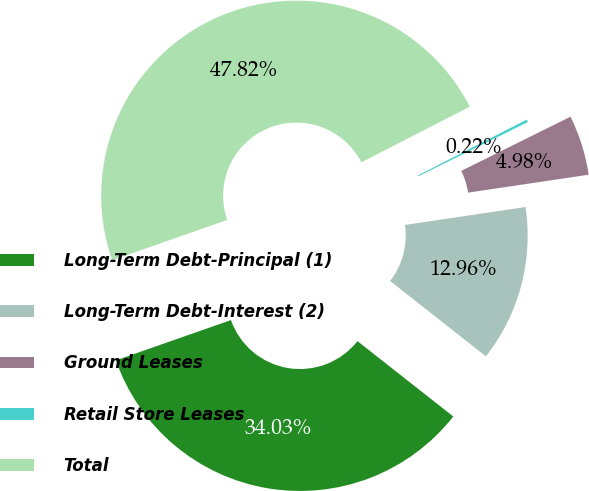Convert chart to OTSL. <chart><loc_0><loc_0><loc_500><loc_500><pie_chart><fcel>Long-Term Debt-Principal (1)<fcel>Long-Term Debt-Interest (2)<fcel>Ground Leases<fcel>Retail Store Leases<fcel>Total<nl><fcel>34.03%<fcel>12.96%<fcel>4.98%<fcel>0.22%<fcel>47.82%<nl></chart> 